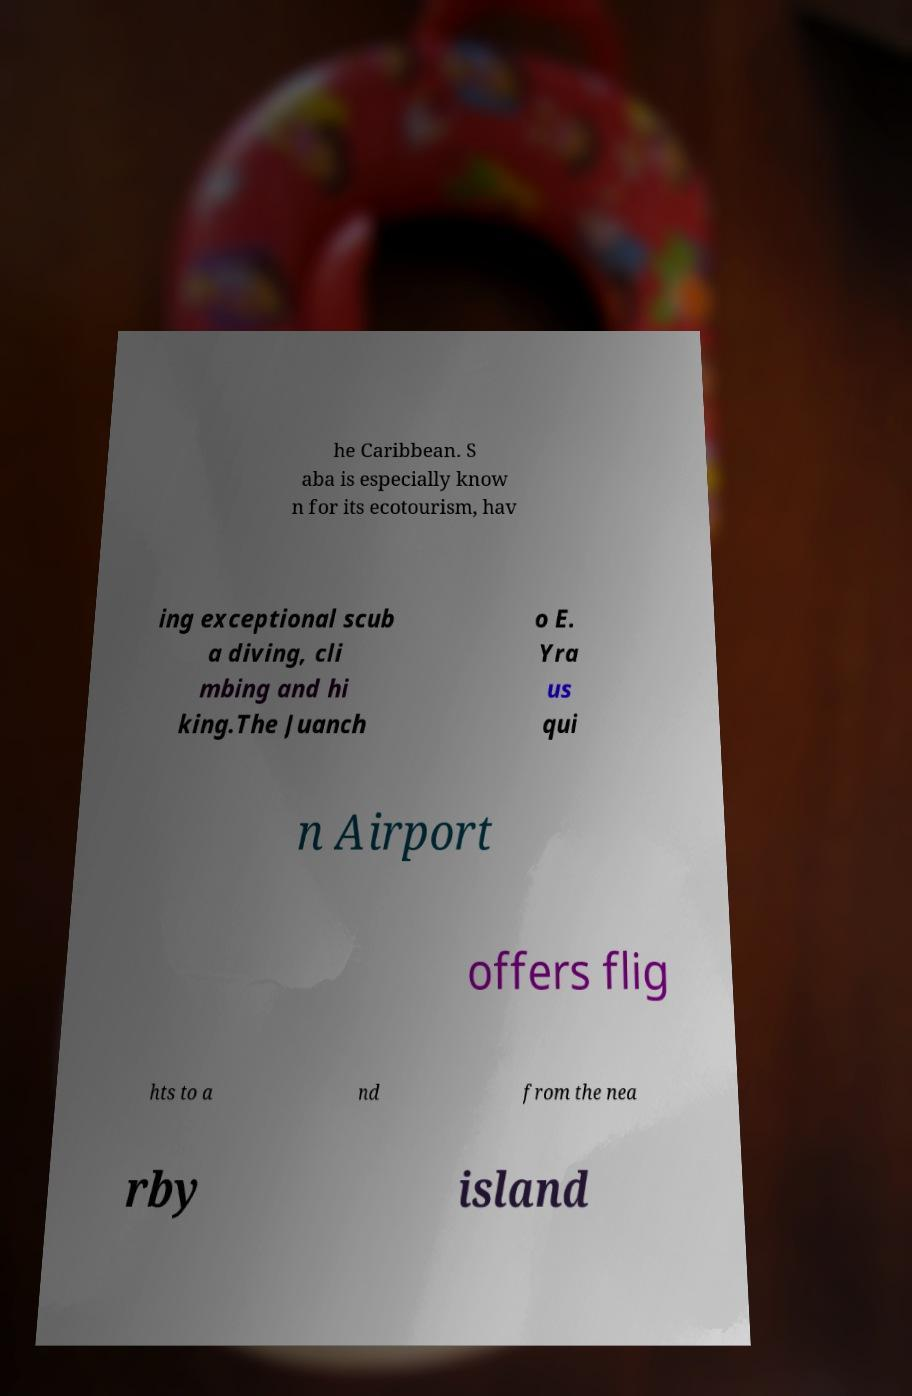Can you read and provide the text displayed in the image?This photo seems to have some interesting text. Can you extract and type it out for me? he Caribbean. S aba is especially know n for its ecotourism, hav ing exceptional scub a diving, cli mbing and hi king.The Juanch o E. Yra us qui n Airport offers flig hts to a nd from the nea rby island 